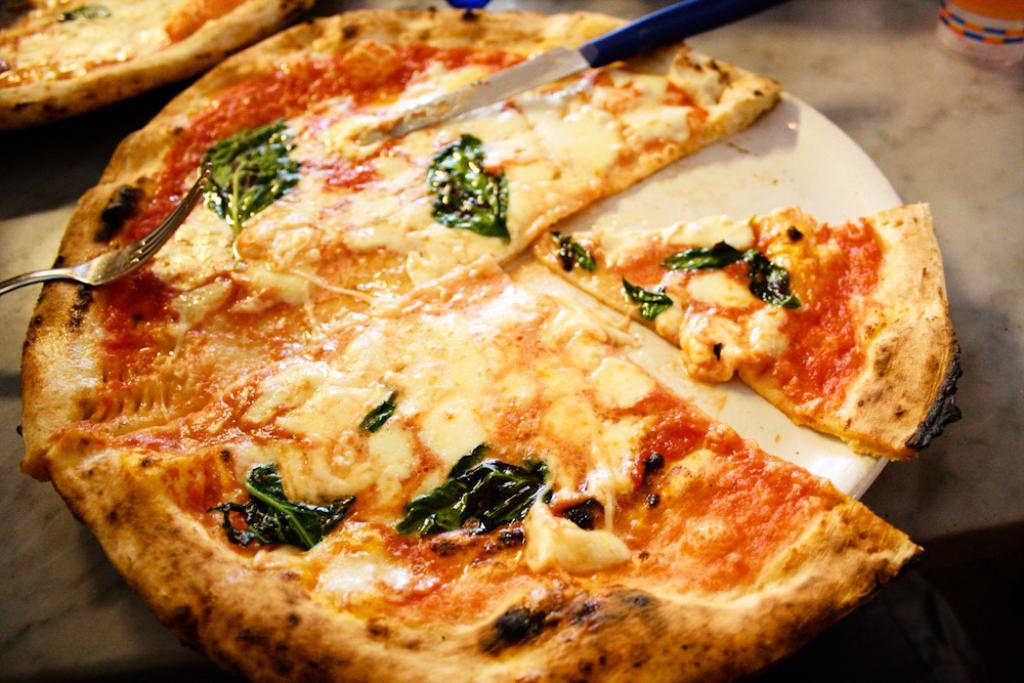What type of food can be seen in the image? There are pizzas in the image. What utensil is visible in the image? A knife is visible in the image. What other utensils can be seen in the image? There are forks in the image. What are the pizzas placed on in the image? There are plates in the image. On what surface are the objects placed? The objects are on a surface. What type of apparel is being worn by the pizza in the image? There are no pizzas wearing apparel in the image, as pizzas are not capable of wearing clothing. 